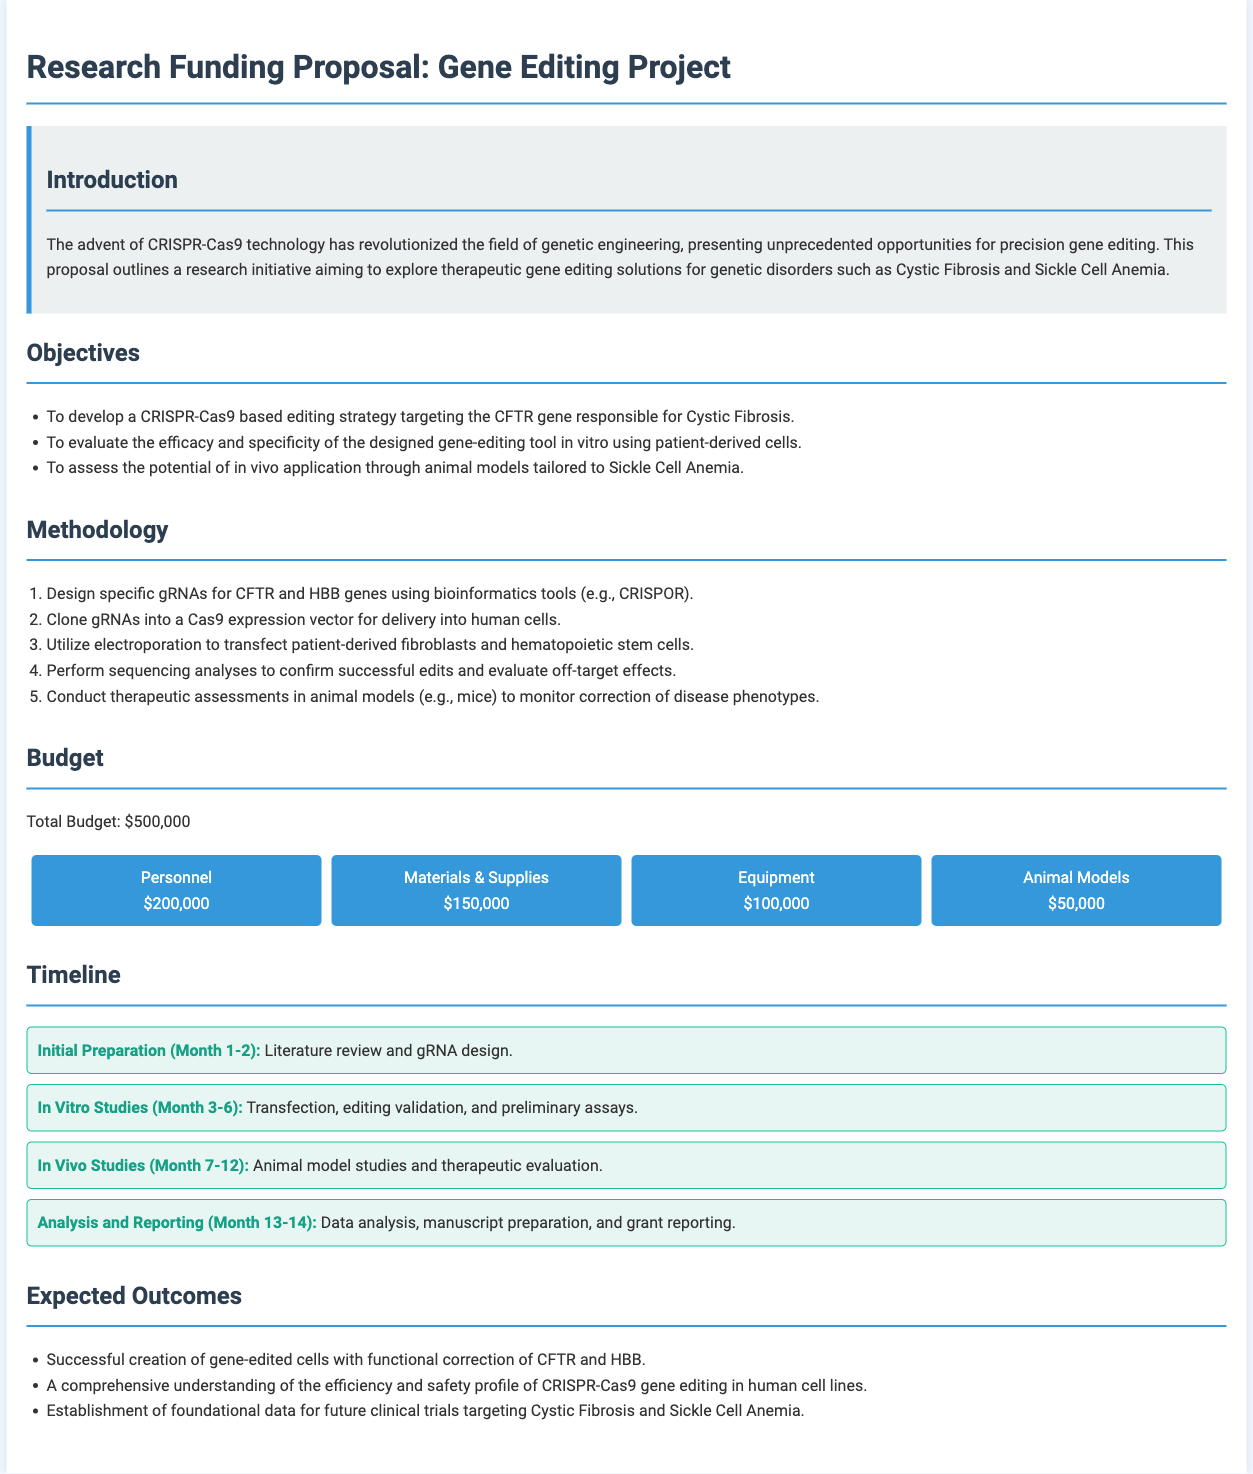What is the total budget for the project? The total budget is stated in the budget section of the document as $500,000.
Answer: $500,000 What gene is targeted for Cystic Fibrosis? The proposal mentions the CFTR gene as the target for Cystic Fibrosis.
Answer: CFTR What animal models will be used in the project? The proposal specifies the use of mice in the in vivo studies.
Answer: Mice What is the first phase of the timeline? The initial phase of the timeline is described as "Initial Preparation (Month 1-2)".
Answer: Initial Preparation (Month 1-2) How much funding is allocated for personnel? The budget section states that $200,000 is allocated for personnel.
Answer: $200,000 What methodology is utilized for transfection? The document mentions electroporation as the method for transfection.
Answer: Electroporation What is the expected outcome related to human cell lines? The document states the expected outcome includes a comprehensive understanding of efficiency and safety in human cell lines.
Answer: Efficiency and safety profile How long is the analysis and reporting phase? The analysis and reporting phase is scheduled for Month 13-14, indicating a duration of 2 months.
Answer: 2 months 